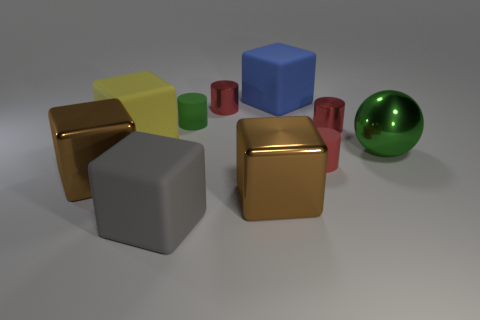There is a large blue object that is the same shape as the large gray matte object; what is it made of?
Provide a short and direct response. Rubber. What number of small red rubber things have the same shape as the big yellow rubber object?
Provide a succinct answer. 0. Is the number of yellow rubber objects on the right side of the red rubber thing greater than the number of large brown shiny objects in front of the gray block?
Your answer should be very brief. No. Do the sphere and the tiny matte cylinder that is behind the yellow thing have the same color?
Offer a very short reply. Yes. What material is the blue object that is the same size as the gray rubber thing?
Keep it short and to the point. Rubber. How many objects are large brown metal spheres or tiny metallic things that are left of the blue cube?
Your answer should be compact. 1. There is a gray thing; is its size the same as the shiny cylinder in front of the green matte object?
Ensure brevity in your answer.  No. How many cylinders are either yellow matte objects or large objects?
Provide a succinct answer. 0. How many small objects are behind the big yellow rubber block and on the right side of the blue rubber thing?
Your answer should be compact. 1. What number of other things are the same color as the metallic sphere?
Offer a very short reply. 1. 